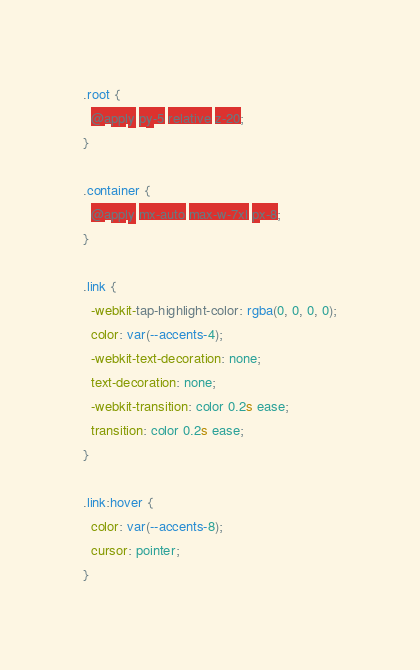<code> <loc_0><loc_0><loc_500><loc_500><_CSS_>.root {
  @apply py-5 relative z-20;
}

.container {
  @apply mx-auto max-w-7xl px-8;
}

.link {
  -webkit-tap-highlight-color: rgba(0, 0, 0, 0);
  color: var(--accents-4);
  -webkit-text-decoration: none;
  text-decoration: none;
  -webkit-transition: color 0.2s ease;
  transition: color 0.2s ease;
}

.link:hover {
  color: var(--accents-8);
  cursor: pointer;
}
</code> 